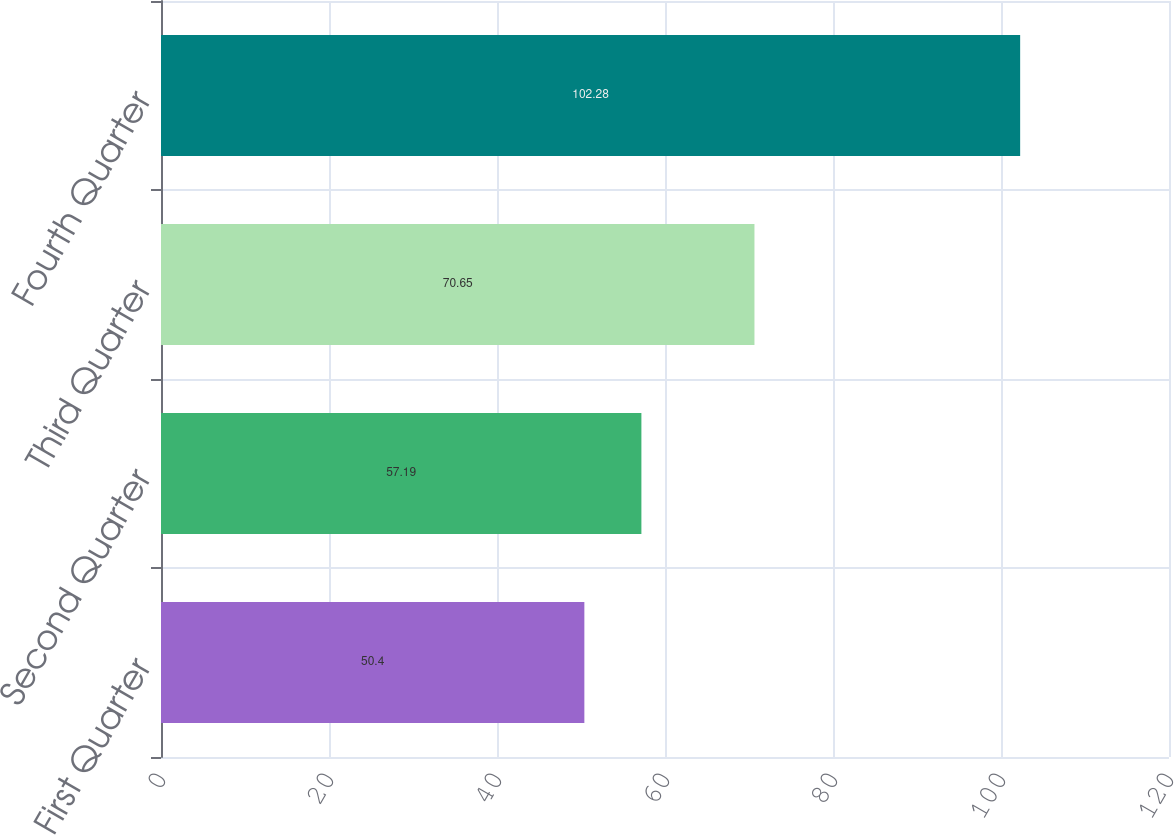Convert chart. <chart><loc_0><loc_0><loc_500><loc_500><bar_chart><fcel>First Quarter<fcel>Second Quarter<fcel>Third Quarter<fcel>Fourth Quarter<nl><fcel>50.4<fcel>57.19<fcel>70.65<fcel>102.28<nl></chart> 